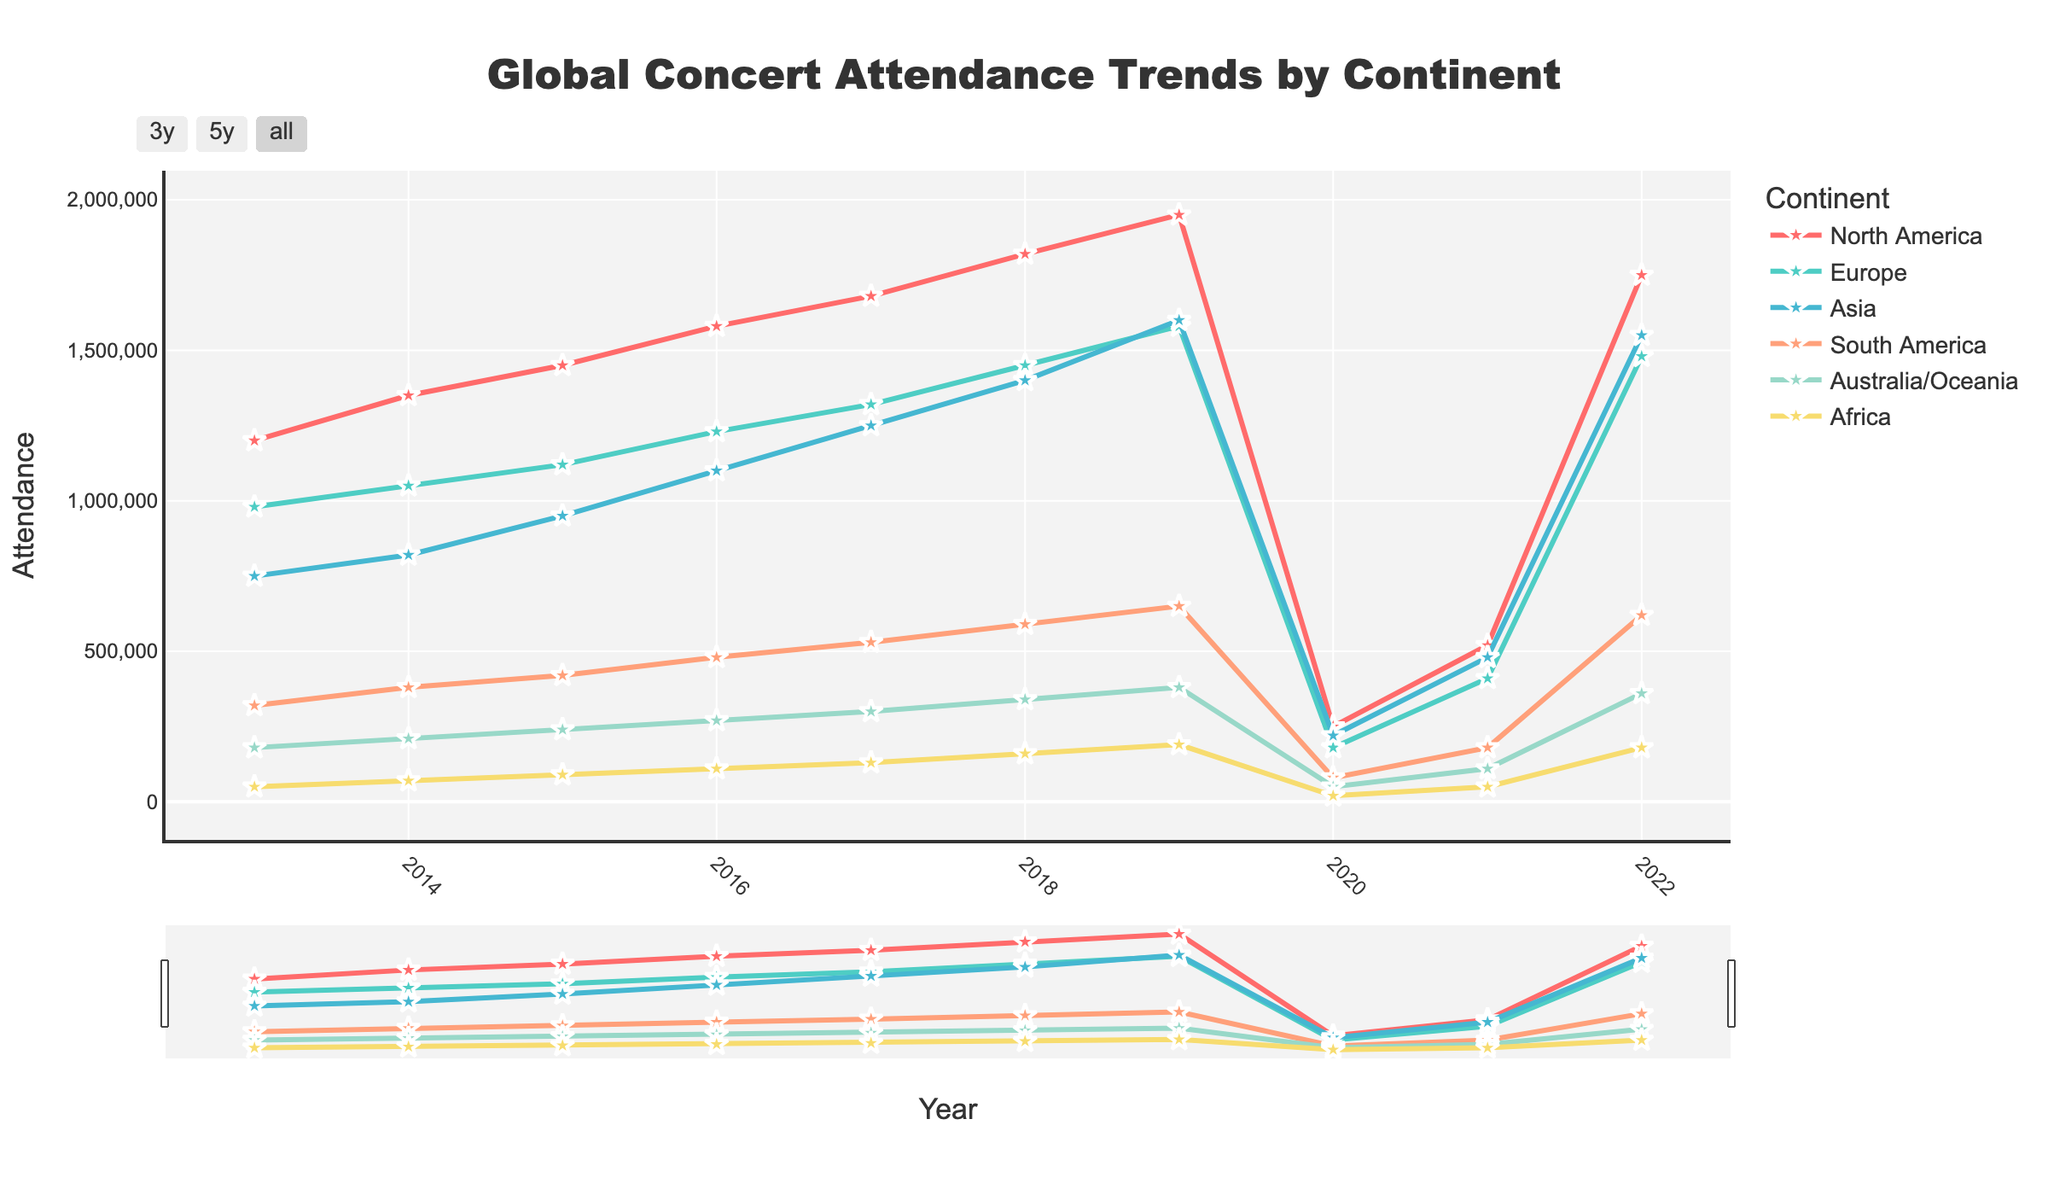What year had the highest attendance in North America? To find the year with the highest attendance in North America, look at the North American data and identify the peak value. From the line chart, the highest point for North America is around 1,950,000 attendees, which corresponds to the year 2019
Answer: 2019 How did concert attendance in Europe compare between 2017 and 2019? Check the attendance figures for Europe in the years 2017 and 2019. The attendance in 2017 was 1,320,000 and increased to 1,580,000 in 2019, showing a growth over these two years.
Answer: Increased Which continent saw the maximum dip in attendance in 2020? Examine the data points for all continents in 2020 and compare them with the previous year's data. The biggest drop is in North America, which went from 1,950,000 in 2019 to 250,000 in 2020.
Answer: North America What is the average attendance across all continents in 2015? Calculate the mean for the 2015 attendance values: (1,450,000 + 1,120,000 + 950,000 + 420,000 + 240,000 + 90,000) = 4,270,000. Divide by the number of continents (6).
Answer: 711,667 Which continent had the least attendance growth from 2014 to 2018? Compare the attendance increases for each continent from 2014 to 2018: North America (1,350,000 to 1,820,000), Europe (1,050,000 to 1,450,000), Asia (820,000 to 1,400,000), South America (380,000 to 590,000), Australia/Oceania (210,000 to 340,000), Africa (70,000 to 160,000). Africa has the least growth.
Answer: Africa In which year did South American concert attendance first exceed half a million? Examine South America's attendance data for each year and determine the first year it surpasses 500,000 attendees. This happens in 2017 with 530,000 attendees.
Answer: 2017 Was the attendance higher in Asia or Europe in 2022? Check the attendance figures for Asia and Europe in 2022. Asia has 1,550,000, and Europe has 1,480,000. Asia has higher attendance.
Answer: Asia Calculate the sum of attendance for all continents in 2019. Add the attendance values for 2019 across all continents: 1,950,000 (North America) + 1,580,000 (Europe) + 1,600,000 (Asia) + 650,000 (South America) + 380,000 (Australia/Oceania) + 190,000 (Africa). The total is 6,350,000.
Answer: 6,350,000 Which year shows the steepest increase in attendance for Australia/Oceania? Identify the year-to-year differences in attendance for Australia/Oceania and determine the highest increase. The steepest increase is from 2019 (380,000) to 2022 (360,000) after the drop in 2020 and 2021 due to the pandemic.
Answer: 2022 